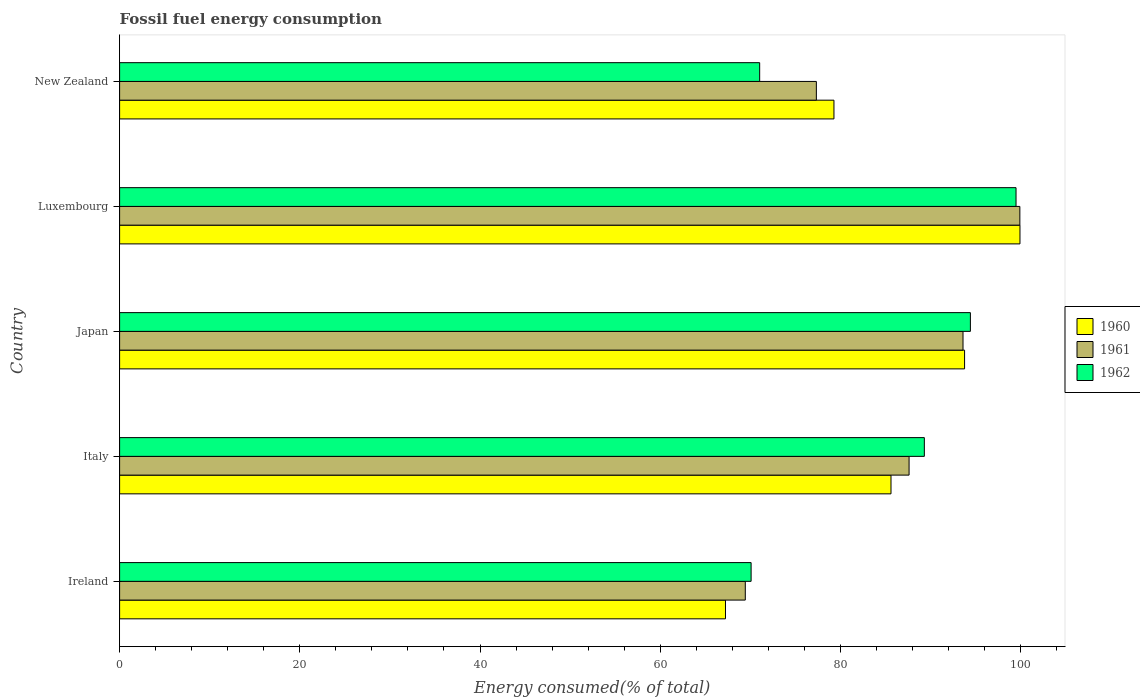How many different coloured bars are there?
Make the answer very short. 3. Are the number of bars per tick equal to the number of legend labels?
Offer a very short reply. Yes. How many bars are there on the 5th tick from the top?
Keep it short and to the point. 3. What is the label of the 3rd group of bars from the top?
Make the answer very short. Japan. In how many cases, is the number of bars for a given country not equal to the number of legend labels?
Give a very brief answer. 0. What is the percentage of energy consumed in 1960 in New Zealand?
Your answer should be compact. 79.28. Across all countries, what is the maximum percentage of energy consumed in 1961?
Keep it short and to the point. 99.91. Across all countries, what is the minimum percentage of energy consumed in 1961?
Provide a succinct answer. 69.44. In which country was the percentage of energy consumed in 1961 maximum?
Provide a short and direct response. Luxembourg. In which country was the percentage of energy consumed in 1962 minimum?
Your response must be concise. Ireland. What is the total percentage of energy consumed in 1962 in the graph?
Ensure brevity in your answer.  424.34. What is the difference between the percentage of energy consumed in 1962 in Japan and that in Luxembourg?
Your response must be concise. -5.07. What is the difference between the percentage of energy consumed in 1962 in New Zealand and the percentage of energy consumed in 1961 in Ireland?
Your answer should be compact. 1.6. What is the average percentage of energy consumed in 1960 per country?
Keep it short and to the point. 85.17. What is the difference between the percentage of energy consumed in 1960 and percentage of energy consumed in 1961 in Japan?
Keep it short and to the point. 0.17. What is the ratio of the percentage of energy consumed in 1960 in Ireland to that in Japan?
Offer a very short reply. 0.72. Is the percentage of energy consumed in 1961 in Japan less than that in Luxembourg?
Make the answer very short. Yes. What is the difference between the highest and the second highest percentage of energy consumed in 1962?
Keep it short and to the point. 5.07. What is the difference between the highest and the lowest percentage of energy consumed in 1960?
Ensure brevity in your answer.  32.68. What does the 2nd bar from the top in Italy represents?
Give a very brief answer. 1961. What does the 1st bar from the bottom in Japan represents?
Your response must be concise. 1960. Is it the case that in every country, the sum of the percentage of energy consumed in 1960 and percentage of energy consumed in 1961 is greater than the percentage of energy consumed in 1962?
Provide a short and direct response. Yes. How many legend labels are there?
Give a very brief answer. 3. How are the legend labels stacked?
Provide a short and direct response. Vertical. What is the title of the graph?
Give a very brief answer. Fossil fuel energy consumption. Does "2014" appear as one of the legend labels in the graph?
Provide a short and direct response. No. What is the label or title of the X-axis?
Your answer should be compact. Energy consumed(% of total). What is the Energy consumed(% of total) in 1960 in Ireland?
Offer a terse response. 67.24. What is the Energy consumed(% of total) in 1961 in Ireland?
Ensure brevity in your answer.  69.44. What is the Energy consumed(% of total) of 1962 in Ireland?
Your answer should be compact. 70.09. What is the Energy consumed(% of total) of 1960 in Italy?
Ensure brevity in your answer.  85.61. What is the Energy consumed(% of total) in 1961 in Italy?
Your answer should be very brief. 87.62. What is the Energy consumed(% of total) in 1962 in Italy?
Your answer should be very brief. 89.31. What is the Energy consumed(% of total) in 1960 in Japan?
Offer a very short reply. 93.78. What is the Energy consumed(% of total) of 1961 in Japan?
Give a very brief answer. 93.6. What is the Energy consumed(% of total) in 1962 in Japan?
Make the answer very short. 94.42. What is the Energy consumed(% of total) of 1960 in Luxembourg?
Ensure brevity in your answer.  99.92. What is the Energy consumed(% of total) in 1961 in Luxembourg?
Your answer should be compact. 99.91. What is the Energy consumed(% of total) of 1962 in Luxembourg?
Your answer should be very brief. 99.49. What is the Energy consumed(% of total) of 1960 in New Zealand?
Make the answer very short. 79.28. What is the Energy consumed(% of total) in 1961 in New Zealand?
Your answer should be compact. 77.33. What is the Energy consumed(% of total) of 1962 in New Zealand?
Offer a terse response. 71.04. Across all countries, what is the maximum Energy consumed(% of total) in 1960?
Provide a short and direct response. 99.92. Across all countries, what is the maximum Energy consumed(% of total) of 1961?
Ensure brevity in your answer.  99.91. Across all countries, what is the maximum Energy consumed(% of total) of 1962?
Give a very brief answer. 99.49. Across all countries, what is the minimum Energy consumed(% of total) in 1960?
Your answer should be compact. 67.24. Across all countries, what is the minimum Energy consumed(% of total) of 1961?
Your response must be concise. 69.44. Across all countries, what is the minimum Energy consumed(% of total) in 1962?
Your answer should be compact. 70.09. What is the total Energy consumed(% of total) in 1960 in the graph?
Offer a very short reply. 425.83. What is the total Energy consumed(% of total) in 1961 in the graph?
Offer a very short reply. 427.9. What is the total Energy consumed(% of total) in 1962 in the graph?
Offer a very short reply. 424.34. What is the difference between the Energy consumed(% of total) in 1960 in Ireland and that in Italy?
Offer a very short reply. -18.37. What is the difference between the Energy consumed(% of total) in 1961 in Ireland and that in Italy?
Your response must be concise. -18.18. What is the difference between the Energy consumed(% of total) in 1962 in Ireland and that in Italy?
Ensure brevity in your answer.  -19.23. What is the difference between the Energy consumed(% of total) of 1960 in Ireland and that in Japan?
Offer a terse response. -26.53. What is the difference between the Energy consumed(% of total) of 1961 in Ireland and that in Japan?
Offer a terse response. -24.16. What is the difference between the Energy consumed(% of total) of 1962 in Ireland and that in Japan?
Your answer should be compact. -24.34. What is the difference between the Energy consumed(% of total) in 1960 in Ireland and that in Luxembourg?
Provide a succinct answer. -32.68. What is the difference between the Energy consumed(% of total) in 1961 in Ireland and that in Luxembourg?
Your answer should be very brief. -30.47. What is the difference between the Energy consumed(% of total) of 1962 in Ireland and that in Luxembourg?
Give a very brief answer. -29.4. What is the difference between the Energy consumed(% of total) in 1960 in Ireland and that in New Zealand?
Your response must be concise. -12.04. What is the difference between the Energy consumed(% of total) of 1961 in Ireland and that in New Zealand?
Give a very brief answer. -7.89. What is the difference between the Energy consumed(% of total) in 1962 in Ireland and that in New Zealand?
Keep it short and to the point. -0.95. What is the difference between the Energy consumed(% of total) of 1960 in Italy and that in Japan?
Offer a very short reply. -8.17. What is the difference between the Energy consumed(% of total) in 1961 in Italy and that in Japan?
Provide a short and direct response. -5.99. What is the difference between the Energy consumed(% of total) in 1962 in Italy and that in Japan?
Make the answer very short. -5.11. What is the difference between the Energy consumed(% of total) of 1960 in Italy and that in Luxembourg?
Provide a short and direct response. -14.31. What is the difference between the Energy consumed(% of total) of 1961 in Italy and that in Luxembourg?
Your response must be concise. -12.3. What is the difference between the Energy consumed(% of total) in 1962 in Italy and that in Luxembourg?
Provide a short and direct response. -10.18. What is the difference between the Energy consumed(% of total) of 1960 in Italy and that in New Zealand?
Give a very brief answer. 6.33. What is the difference between the Energy consumed(% of total) of 1961 in Italy and that in New Zealand?
Your response must be concise. 10.29. What is the difference between the Energy consumed(% of total) of 1962 in Italy and that in New Zealand?
Make the answer very short. 18.27. What is the difference between the Energy consumed(% of total) in 1960 in Japan and that in Luxembourg?
Make the answer very short. -6.15. What is the difference between the Energy consumed(% of total) in 1961 in Japan and that in Luxembourg?
Provide a short and direct response. -6.31. What is the difference between the Energy consumed(% of total) of 1962 in Japan and that in Luxembourg?
Offer a terse response. -5.07. What is the difference between the Energy consumed(% of total) of 1960 in Japan and that in New Zealand?
Give a very brief answer. 14.5. What is the difference between the Energy consumed(% of total) of 1961 in Japan and that in New Zealand?
Provide a short and direct response. 16.28. What is the difference between the Energy consumed(% of total) of 1962 in Japan and that in New Zealand?
Your answer should be compact. 23.38. What is the difference between the Energy consumed(% of total) in 1960 in Luxembourg and that in New Zealand?
Your answer should be compact. 20.65. What is the difference between the Energy consumed(% of total) in 1961 in Luxembourg and that in New Zealand?
Ensure brevity in your answer.  22.58. What is the difference between the Energy consumed(% of total) of 1962 in Luxembourg and that in New Zealand?
Provide a short and direct response. 28.45. What is the difference between the Energy consumed(% of total) of 1960 in Ireland and the Energy consumed(% of total) of 1961 in Italy?
Make the answer very short. -20.38. What is the difference between the Energy consumed(% of total) in 1960 in Ireland and the Energy consumed(% of total) in 1962 in Italy?
Make the answer very short. -22.07. What is the difference between the Energy consumed(% of total) in 1961 in Ireland and the Energy consumed(% of total) in 1962 in Italy?
Your answer should be very brief. -19.87. What is the difference between the Energy consumed(% of total) of 1960 in Ireland and the Energy consumed(% of total) of 1961 in Japan?
Provide a succinct answer. -26.36. What is the difference between the Energy consumed(% of total) in 1960 in Ireland and the Energy consumed(% of total) in 1962 in Japan?
Offer a very short reply. -27.18. What is the difference between the Energy consumed(% of total) in 1961 in Ireland and the Energy consumed(% of total) in 1962 in Japan?
Give a very brief answer. -24.98. What is the difference between the Energy consumed(% of total) in 1960 in Ireland and the Energy consumed(% of total) in 1961 in Luxembourg?
Offer a very short reply. -32.67. What is the difference between the Energy consumed(% of total) of 1960 in Ireland and the Energy consumed(% of total) of 1962 in Luxembourg?
Ensure brevity in your answer.  -32.25. What is the difference between the Energy consumed(% of total) in 1961 in Ireland and the Energy consumed(% of total) in 1962 in Luxembourg?
Your response must be concise. -30.05. What is the difference between the Energy consumed(% of total) in 1960 in Ireland and the Energy consumed(% of total) in 1961 in New Zealand?
Your response must be concise. -10.09. What is the difference between the Energy consumed(% of total) of 1960 in Ireland and the Energy consumed(% of total) of 1962 in New Zealand?
Offer a terse response. -3.79. What is the difference between the Energy consumed(% of total) of 1961 in Ireland and the Energy consumed(% of total) of 1962 in New Zealand?
Provide a short and direct response. -1.6. What is the difference between the Energy consumed(% of total) of 1960 in Italy and the Energy consumed(% of total) of 1961 in Japan?
Make the answer very short. -7.99. What is the difference between the Energy consumed(% of total) of 1960 in Italy and the Energy consumed(% of total) of 1962 in Japan?
Ensure brevity in your answer.  -8.81. What is the difference between the Energy consumed(% of total) of 1961 in Italy and the Energy consumed(% of total) of 1962 in Japan?
Ensure brevity in your answer.  -6.8. What is the difference between the Energy consumed(% of total) in 1960 in Italy and the Energy consumed(% of total) in 1961 in Luxembourg?
Ensure brevity in your answer.  -14.3. What is the difference between the Energy consumed(% of total) of 1960 in Italy and the Energy consumed(% of total) of 1962 in Luxembourg?
Provide a short and direct response. -13.88. What is the difference between the Energy consumed(% of total) of 1961 in Italy and the Energy consumed(% of total) of 1962 in Luxembourg?
Keep it short and to the point. -11.87. What is the difference between the Energy consumed(% of total) of 1960 in Italy and the Energy consumed(% of total) of 1961 in New Zealand?
Keep it short and to the point. 8.28. What is the difference between the Energy consumed(% of total) in 1960 in Italy and the Energy consumed(% of total) in 1962 in New Zealand?
Offer a terse response. 14.57. What is the difference between the Energy consumed(% of total) in 1961 in Italy and the Energy consumed(% of total) in 1962 in New Zealand?
Provide a succinct answer. 16.58. What is the difference between the Energy consumed(% of total) in 1960 in Japan and the Energy consumed(% of total) in 1961 in Luxembourg?
Offer a terse response. -6.14. What is the difference between the Energy consumed(% of total) of 1960 in Japan and the Energy consumed(% of total) of 1962 in Luxembourg?
Your answer should be compact. -5.71. What is the difference between the Energy consumed(% of total) of 1961 in Japan and the Energy consumed(% of total) of 1962 in Luxembourg?
Your response must be concise. -5.88. What is the difference between the Energy consumed(% of total) of 1960 in Japan and the Energy consumed(% of total) of 1961 in New Zealand?
Ensure brevity in your answer.  16.45. What is the difference between the Energy consumed(% of total) in 1960 in Japan and the Energy consumed(% of total) in 1962 in New Zealand?
Your response must be concise. 22.74. What is the difference between the Energy consumed(% of total) of 1961 in Japan and the Energy consumed(% of total) of 1962 in New Zealand?
Offer a terse response. 22.57. What is the difference between the Energy consumed(% of total) of 1960 in Luxembourg and the Energy consumed(% of total) of 1961 in New Zealand?
Offer a terse response. 22.6. What is the difference between the Energy consumed(% of total) of 1960 in Luxembourg and the Energy consumed(% of total) of 1962 in New Zealand?
Keep it short and to the point. 28.89. What is the difference between the Energy consumed(% of total) of 1961 in Luxembourg and the Energy consumed(% of total) of 1962 in New Zealand?
Provide a short and direct response. 28.88. What is the average Energy consumed(% of total) of 1960 per country?
Provide a short and direct response. 85.17. What is the average Energy consumed(% of total) in 1961 per country?
Offer a terse response. 85.58. What is the average Energy consumed(% of total) in 1962 per country?
Provide a succinct answer. 84.87. What is the difference between the Energy consumed(% of total) of 1960 and Energy consumed(% of total) of 1961 in Ireland?
Offer a very short reply. -2.2. What is the difference between the Energy consumed(% of total) of 1960 and Energy consumed(% of total) of 1962 in Ireland?
Keep it short and to the point. -2.84. What is the difference between the Energy consumed(% of total) in 1961 and Energy consumed(% of total) in 1962 in Ireland?
Offer a terse response. -0.65. What is the difference between the Energy consumed(% of total) of 1960 and Energy consumed(% of total) of 1961 in Italy?
Provide a short and direct response. -2.01. What is the difference between the Energy consumed(% of total) of 1960 and Energy consumed(% of total) of 1962 in Italy?
Provide a succinct answer. -3.7. What is the difference between the Energy consumed(% of total) in 1961 and Energy consumed(% of total) in 1962 in Italy?
Your response must be concise. -1.69. What is the difference between the Energy consumed(% of total) in 1960 and Energy consumed(% of total) in 1961 in Japan?
Give a very brief answer. 0.17. What is the difference between the Energy consumed(% of total) of 1960 and Energy consumed(% of total) of 1962 in Japan?
Make the answer very short. -0.64. What is the difference between the Energy consumed(% of total) of 1961 and Energy consumed(% of total) of 1962 in Japan?
Provide a short and direct response. -0.82. What is the difference between the Energy consumed(% of total) in 1960 and Energy consumed(% of total) in 1961 in Luxembourg?
Ensure brevity in your answer.  0.01. What is the difference between the Energy consumed(% of total) in 1960 and Energy consumed(% of total) in 1962 in Luxembourg?
Your response must be concise. 0.44. What is the difference between the Energy consumed(% of total) in 1961 and Energy consumed(% of total) in 1962 in Luxembourg?
Offer a terse response. 0.42. What is the difference between the Energy consumed(% of total) in 1960 and Energy consumed(% of total) in 1961 in New Zealand?
Your answer should be compact. 1.95. What is the difference between the Energy consumed(% of total) of 1960 and Energy consumed(% of total) of 1962 in New Zealand?
Your answer should be very brief. 8.24. What is the difference between the Energy consumed(% of total) of 1961 and Energy consumed(% of total) of 1962 in New Zealand?
Your answer should be very brief. 6.29. What is the ratio of the Energy consumed(% of total) in 1960 in Ireland to that in Italy?
Offer a terse response. 0.79. What is the ratio of the Energy consumed(% of total) in 1961 in Ireland to that in Italy?
Provide a short and direct response. 0.79. What is the ratio of the Energy consumed(% of total) in 1962 in Ireland to that in Italy?
Make the answer very short. 0.78. What is the ratio of the Energy consumed(% of total) of 1960 in Ireland to that in Japan?
Your answer should be very brief. 0.72. What is the ratio of the Energy consumed(% of total) in 1961 in Ireland to that in Japan?
Keep it short and to the point. 0.74. What is the ratio of the Energy consumed(% of total) of 1962 in Ireland to that in Japan?
Give a very brief answer. 0.74. What is the ratio of the Energy consumed(% of total) of 1960 in Ireland to that in Luxembourg?
Your answer should be compact. 0.67. What is the ratio of the Energy consumed(% of total) in 1961 in Ireland to that in Luxembourg?
Ensure brevity in your answer.  0.69. What is the ratio of the Energy consumed(% of total) in 1962 in Ireland to that in Luxembourg?
Your answer should be compact. 0.7. What is the ratio of the Energy consumed(% of total) in 1960 in Ireland to that in New Zealand?
Your response must be concise. 0.85. What is the ratio of the Energy consumed(% of total) of 1961 in Ireland to that in New Zealand?
Offer a very short reply. 0.9. What is the ratio of the Energy consumed(% of total) in 1962 in Ireland to that in New Zealand?
Your answer should be compact. 0.99. What is the ratio of the Energy consumed(% of total) in 1960 in Italy to that in Japan?
Give a very brief answer. 0.91. What is the ratio of the Energy consumed(% of total) in 1961 in Italy to that in Japan?
Keep it short and to the point. 0.94. What is the ratio of the Energy consumed(% of total) in 1962 in Italy to that in Japan?
Your answer should be very brief. 0.95. What is the ratio of the Energy consumed(% of total) of 1960 in Italy to that in Luxembourg?
Provide a succinct answer. 0.86. What is the ratio of the Energy consumed(% of total) of 1961 in Italy to that in Luxembourg?
Ensure brevity in your answer.  0.88. What is the ratio of the Energy consumed(% of total) in 1962 in Italy to that in Luxembourg?
Provide a short and direct response. 0.9. What is the ratio of the Energy consumed(% of total) in 1960 in Italy to that in New Zealand?
Your response must be concise. 1.08. What is the ratio of the Energy consumed(% of total) of 1961 in Italy to that in New Zealand?
Ensure brevity in your answer.  1.13. What is the ratio of the Energy consumed(% of total) of 1962 in Italy to that in New Zealand?
Give a very brief answer. 1.26. What is the ratio of the Energy consumed(% of total) of 1960 in Japan to that in Luxembourg?
Provide a succinct answer. 0.94. What is the ratio of the Energy consumed(% of total) in 1961 in Japan to that in Luxembourg?
Make the answer very short. 0.94. What is the ratio of the Energy consumed(% of total) in 1962 in Japan to that in Luxembourg?
Offer a terse response. 0.95. What is the ratio of the Energy consumed(% of total) in 1960 in Japan to that in New Zealand?
Your answer should be compact. 1.18. What is the ratio of the Energy consumed(% of total) of 1961 in Japan to that in New Zealand?
Provide a succinct answer. 1.21. What is the ratio of the Energy consumed(% of total) in 1962 in Japan to that in New Zealand?
Provide a succinct answer. 1.33. What is the ratio of the Energy consumed(% of total) of 1960 in Luxembourg to that in New Zealand?
Your response must be concise. 1.26. What is the ratio of the Energy consumed(% of total) of 1961 in Luxembourg to that in New Zealand?
Keep it short and to the point. 1.29. What is the ratio of the Energy consumed(% of total) of 1962 in Luxembourg to that in New Zealand?
Provide a succinct answer. 1.4. What is the difference between the highest and the second highest Energy consumed(% of total) in 1960?
Offer a very short reply. 6.15. What is the difference between the highest and the second highest Energy consumed(% of total) of 1961?
Your answer should be compact. 6.31. What is the difference between the highest and the second highest Energy consumed(% of total) in 1962?
Your response must be concise. 5.07. What is the difference between the highest and the lowest Energy consumed(% of total) in 1960?
Provide a short and direct response. 32.68. What is the difference between the highest and the lowest Energy consumed(% of total) of 1961?
Keep it short and to the point. 30.47. What is the difference between the highest and the lowest Energy consumed(% of total) in 1962?
Provide a succinct answer. 29.4. 